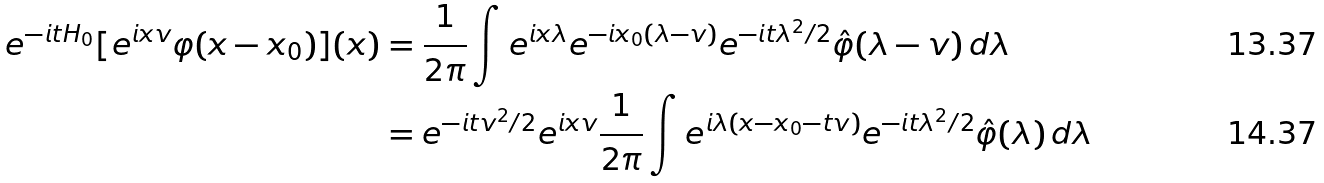Convert formula to latex. <formula><loc_0><loc_0><loc_500><loc_500>e ^ { - i t H _ { 0 } } [ e ^ { i x v } \varphi ( x - x _ { 0 } ) ] ( x ) & = \frac { 1 } { 2 \pi } \int e ^ { i x \lambda } e ^ { - i x _ { 0 } ( \lambda - v ) } e ^ { - i t \lambda ^ { 2 } / 2 } \hat { \varphi } ( \lambda - v ) \, d \lambda \\ & = e ^ { - i t v ^ { 2 } / 2 } e ^ { i x v } \frac { 1 } { 2 \pi } \int e ^ { i \lambda ( x - x _ { 0 } - t v ) } e ^ { - i t \lambda ^ { 2 } / 2 } \hat { \varphi } ( \lambda ) \, d \lambda</formula> 